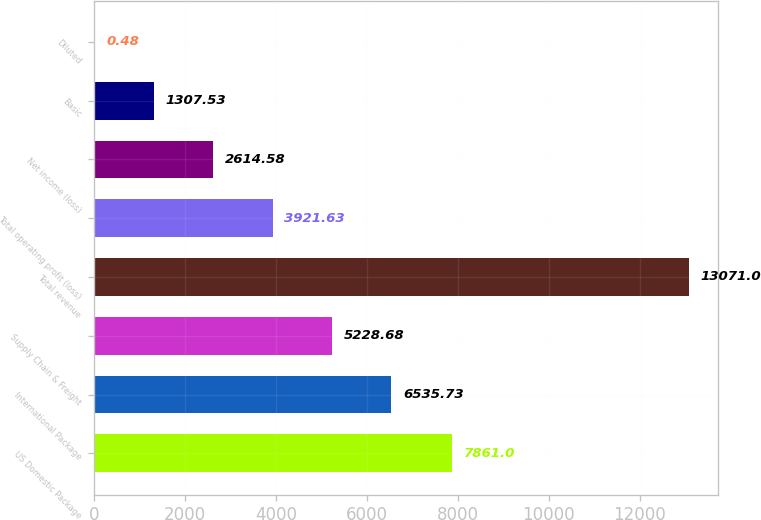<chart> <loc_0><loc_0><loc_500><loc_500><bar_chart><fcel>US Domestic Package<fcel>International Package<fcel>Supply Chain & Freight<fcel>Total revenue<fcel>Total operating profit (loss)<fcel>Net income (loss)<fcel>Basic<fcel>Diluted<nl><fcel>7861<fcel>6535.73<fcel>5228.68<fcel>13071<fcel>3921.63<fcel>2614.58<fcel>1307.53<fcel>0.48<nl></chart> 